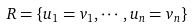<formula> <loc_0><loc_0><loc_500><loc_500>R = \{ u _ { 1 } = v _ { 1 } , \cdots , u _ { n } = v _ { n } \}</formula> 